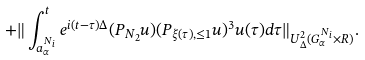Convert formula to latex. <formula><loc_0><loc_0><loc_500><loc_500>+ \| \int _ { a _ { \alpha } ^ { N _ { i } } } ^ { t } e ^ { i ( t - \tau ) \Delta } ( P _ { N _ { 2 } } u ) ( P _ { \xi ( \tau ) , \leq 1 } u ) ^ { 3 } u ( \tau ) d \tau \| _ { U _ { \Delta } ^ { 2 } ( G _ { \alpha } ^ { N _ { i } } \times R ) } .</formula> 